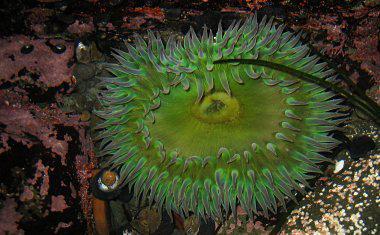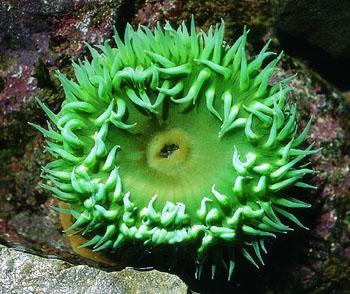The first image is the image on the left, the second image is the image on the right. Assess this claim about the two images: "Left and right images feature one prominent neon-greenish anemone, and a center spot is visible in at least one anemone.". Correct or not? Answer yes or no. Yes. The first image is the image on the left, the second image is the image on the right. For the images shown, is this caption "There are only two Sea anemones" true? Answer yes or no. Yes. 